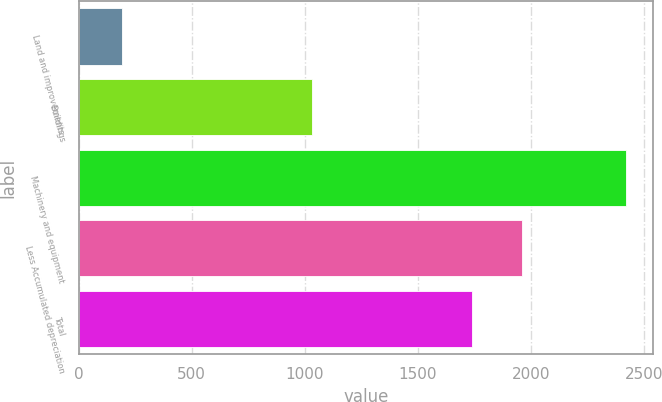<chart> <loc_0><loc_0><loc_500><loc_500><bar_chart><fcel>Land and improvements<fcel>Buildings<fcel>Machinery and equipment<fcel>Less Accumulated depreciation<fcel>Total<nl><fcel>190<fcel>1030<fcel>2419<fcel>1959.9<fcel>1737<nl></chart> 